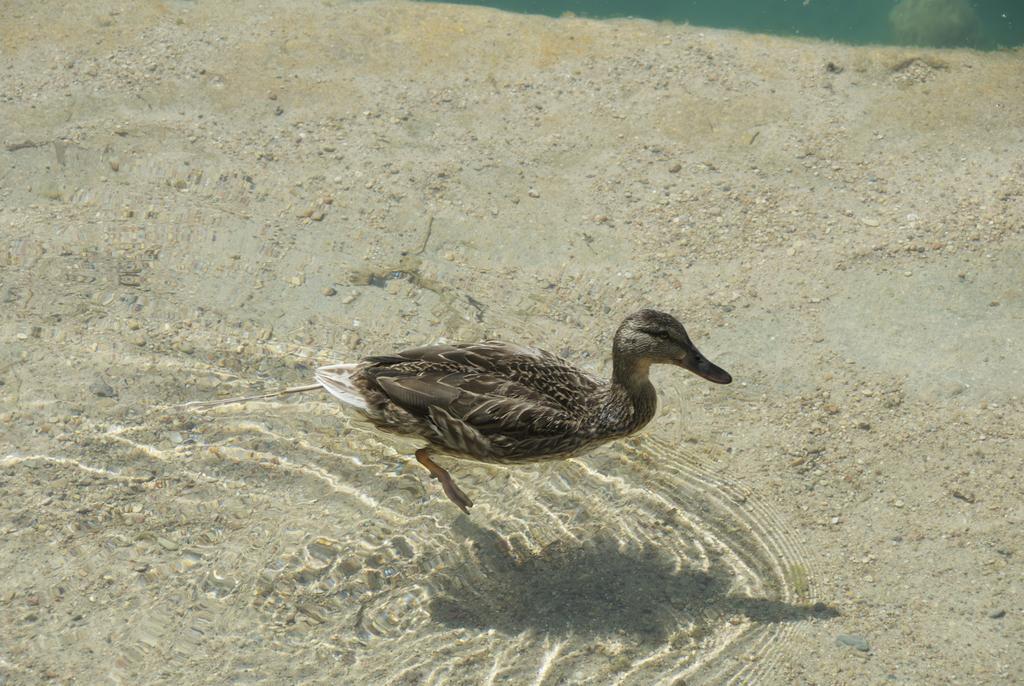Describe this image in one or two sentences. In this picture we can see a duck and sand in the water. 